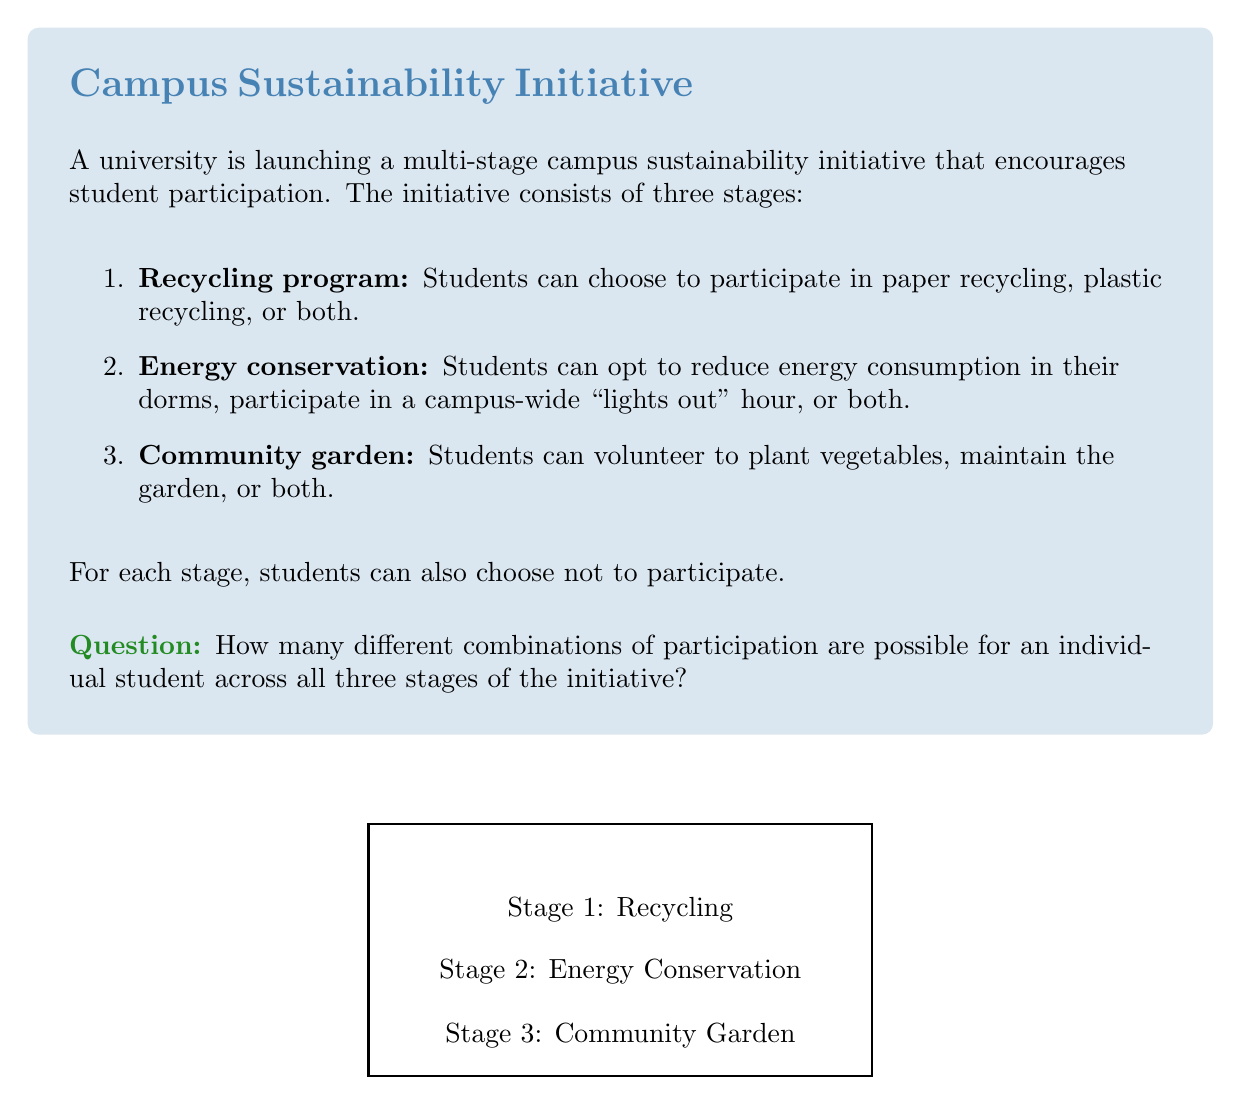Solve this math problem. Let's approach this problem step-by-step using the multiplication principle of counting:

1) For each stage, we need to count the number of possible choices a student can make:

   Stage 1 (Recycling):
   - No participation
   - Paper recycling only
   - Plastic recycling only
   - Both paper and plastic recycling
   Total choices for Stage 1: 4

   Stage 2 (Energy Conservation):
   - No participation
   - Reduce dorm energy only
   - Participate in "lights out" hour only
   - Both reduce dorm energy and participate in "lights out" hour
   Total choices for Stage 2: 4

   Stage 3 (Community Garden):
   - No participation
   - Plant vegetables only
   - Maintain garden only
   - Both plant vegetables and maintain garden
   Total choices for Stage 3: 4

2) Now, for each stage, a student has 4 choices. According to the multiplication principle, if we have a series of independent choices, the total number of possible outcomes is the product of the number of choices for each decision.

3) Therefore, the total number of possible combinations is:

   $$ 4 \times 4 \times 4 = 4^3 = 64 $$

This result reflects the fact that for each of the three stages, a student has 4 choices, and these choices are independent of each other.
Answer: $64$ 